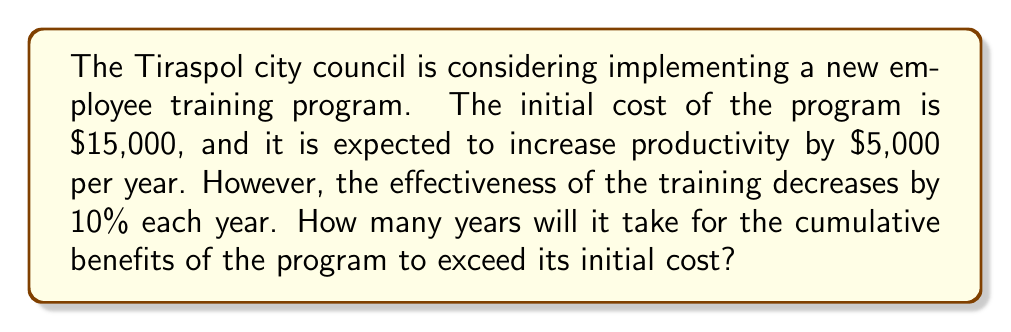Solve this math problem. Let's approach this step-by-step:

1) Let $y$ be the number of years and $B(y)$ be the cumulative benefit after $y$ years.

2) The benefit for each year can be modeled as:
   Year 1: $5000$
   Year 2: $5000 \cdot 0.9 = 4500$
   Year 3: $5000 \cdot 0.9^2 = 4050$
   And so on...

3) We can express this as a geometric series:
   $$B(y) = 5000 + 5000 \cdot 0.9 + 5000 \cdot 0.9^2 + ... + 5000 \cdot 0.9^{y-1}$$

4) The sum of a geometric series is given by the formula:
   $$S_n = \frac{a(1-r^n)}{1-r}$$
   Where $a$ is the first term, $r$ is the common ratio, and $n$ is the number of terms.

5) In our case, $a = 5000$, $r = 0.9$, and $n = y$. So:
   $$B(y) = \frac{5000(1-0.9^y)}{1-0.9} = 50000(1-0.9^y)$$

6) We want to find $y$ where $B(y)$ exceeds 15000:
   $$50000(1-0.9^y) > 15000$$

7) Solving this inequality:
   $$1-0.9^y > 0.3$$
   $$0.9^y < 0.7$$
   $$y \log 0.9 < \log 0.7$$
   $$y > \frac{\log 0.7}{\log 0.9} \approx 3.48$$

8) Since $y$ must be a whole number of years, we round up to 4.
Answer: 4 years 